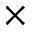Convert formula to latex. <formula><loc_0><loc_0><loc_500><loc_500>\times</formula> 